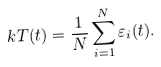Convert formula to latex. <formula><loc_0><loc_0><loc_500><loc_500>k T ( t ) = \frac { 1 } { N } \sum _ { i = 1 } ^ { N } \varepsilon _ { i } ( t ) .</formula> 